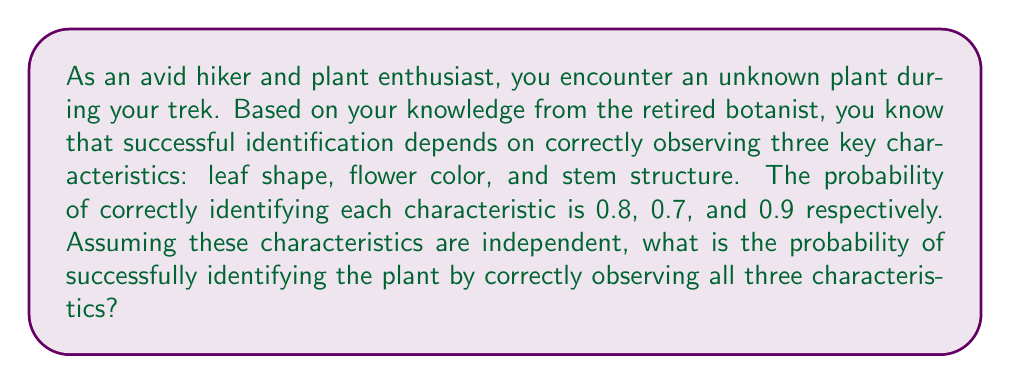Can you solve this math problem? To solve this problem, we need to use the multiplication rule for independent events. Since we need to correctly identify all three characteristics for a successful plant identification, we multiply the probabilities of each individual event.

Let's define our events:
A = Correctly identifying leaf shape (P(A) = 0.8)
B = Correctly identifying flower color (P(B) = 0.7)
C = Correctly identifying stem structure (P(C) = 0.9)

We want to find P(A ∩ B ∩ C), the probability of all three events occurring together.

For independent events, we have:

$$ P(A \cap B \cap C) = P(A) \times P(B) \times P(C) $$

Substituting the given probabilities:

$$ P(A \cap B \cap C) = 0.8 \times 0.7 \times 0.9 $$

Calculating:

$$ P(A \cap B \cap C) = 0.504 $$

Therefore, the probability of successfully identifying the plant by correctly observing all three characteristics is 0.504 or 50.4%.
Answer: 0.504 or 50.4% 